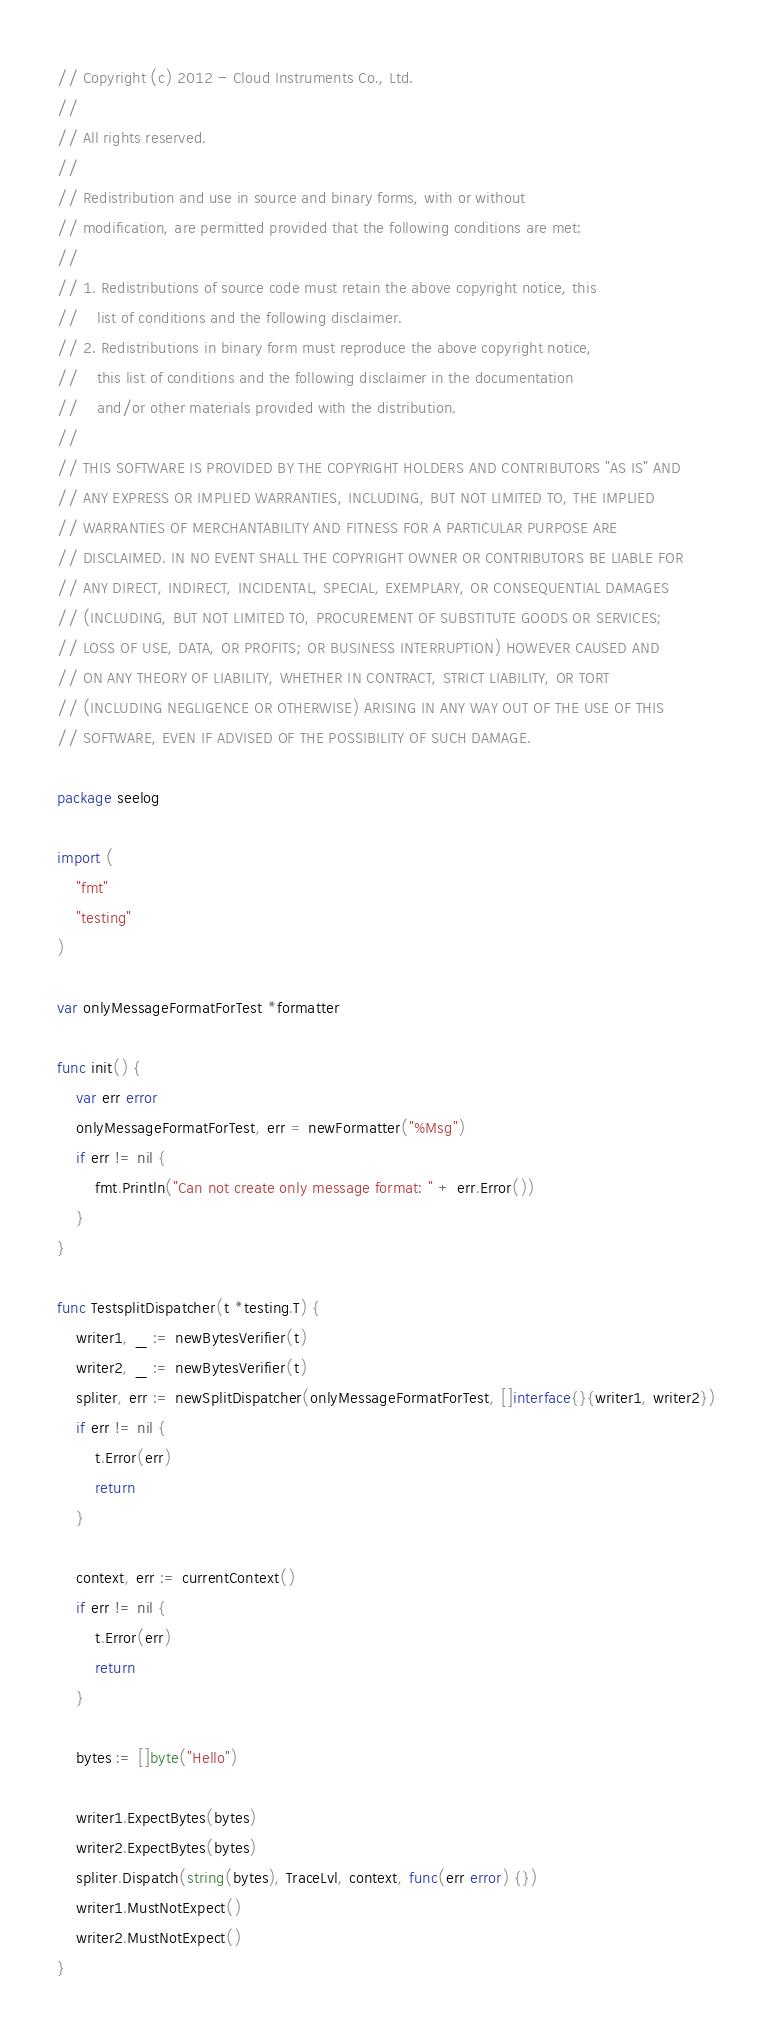<code> <loc_0><loc_0><loc_500><loc_500><_Go_>// Copyright (c) 2012 - Cloud Instruments Co., Ltd.
//
// All rights reserved.
//
// Redistribution and use in source and binary forms, with or without
// modification, are permitted provided that the following conditions are met:
//
// 1. Redistributions of source code must retain the above copyright notice, this
//    list of conditions and the following disclaimer.
// 2. Redistributions in binary form must reproduce the above copyright notice,
//    this list of conditions and the following disclaimer in the documentation
//    and/or other materials provided with the distribution.
//
// THIS SOFTWARE IS PROVIDED BY THE COPYRIGHT HOLDERS AND CONTRIBUTORS "AS IS" AND
// ANY EXPRESS OR IMPLIED WARRANTIES, INCLUDING, BUT NOT LIMITED TO, THE IMPLIED
// WARRANTIES OF MERCHANTABILITY AND FITNESS FOR A PARTICULAR PURPOSE ARE
// DISCLAIMED. IN NO EVENT SHALL THE COPYRIGHT OWNER OR CONTRIBUTORS BE LIABLE FOR
// ANY DIRECT, INDIRECT, INCIDENTAL, SPECIAL, EXEMPLARY, OR CONSEQUENTIAL DAMAGES
// (INCLUDING, BUT NOT LIMITED TO, PROCUREMENT OF SUBSTITUTE GOODS OR SERVICES;
// LOSS OF USE, DATA, OR PROFITS; OR BUSINESS INTERRUPTION) HOWEVER CAUSED AND
// ON ANY THEORY OF LIABILITY, WHETHER IN CONTRACT, STRICT LIABILITY, OR TORT
// (INCLUDING NEGLIGENCE OR OTHERWISE) ARISING IN ANY WAY OUT OF THE USE OF THIS
// SOFTWARE, EVEN IF ADVISED OF THE POSSIBILITY OF SUCH DAMAGE.

package seelog

import (
	"fmt"
	"testing"
)

var onlyMessageFormatForTest *formatter

func init() {
	var err error
	onlyMessageFormatForTest, err = newFormatter("%Msg")
	if err != nil {
		fmt.Println("Can not create only message format: " + err.Error())
	}
}

func TestsplitDispatcher(t *testing.T) {
	writer1, _ := newBytesVerifier(t)
	writer2, _ := newBytesVerifier(t)
	spliter, err := newSplitDispatcher(onlyMessageFormatForTest, []interface{}{writer1, writer2})
	if err != nil {
		t.Error(err)
		return
	}

	context, err := currentContext()
	if err != nil {
		t.Error(err)
		return
	}

	bytes := []byte("Hello")

	writer1.ExpectBytes(bytes)
	writer2.ExpectBytes(bytes)
	spliter.Dispatch(string(bytes), TraceLvl, context, func(err error) {})
	writer1.MustNotExpect()
	writer2.MustNotExpect()
}
</code> 